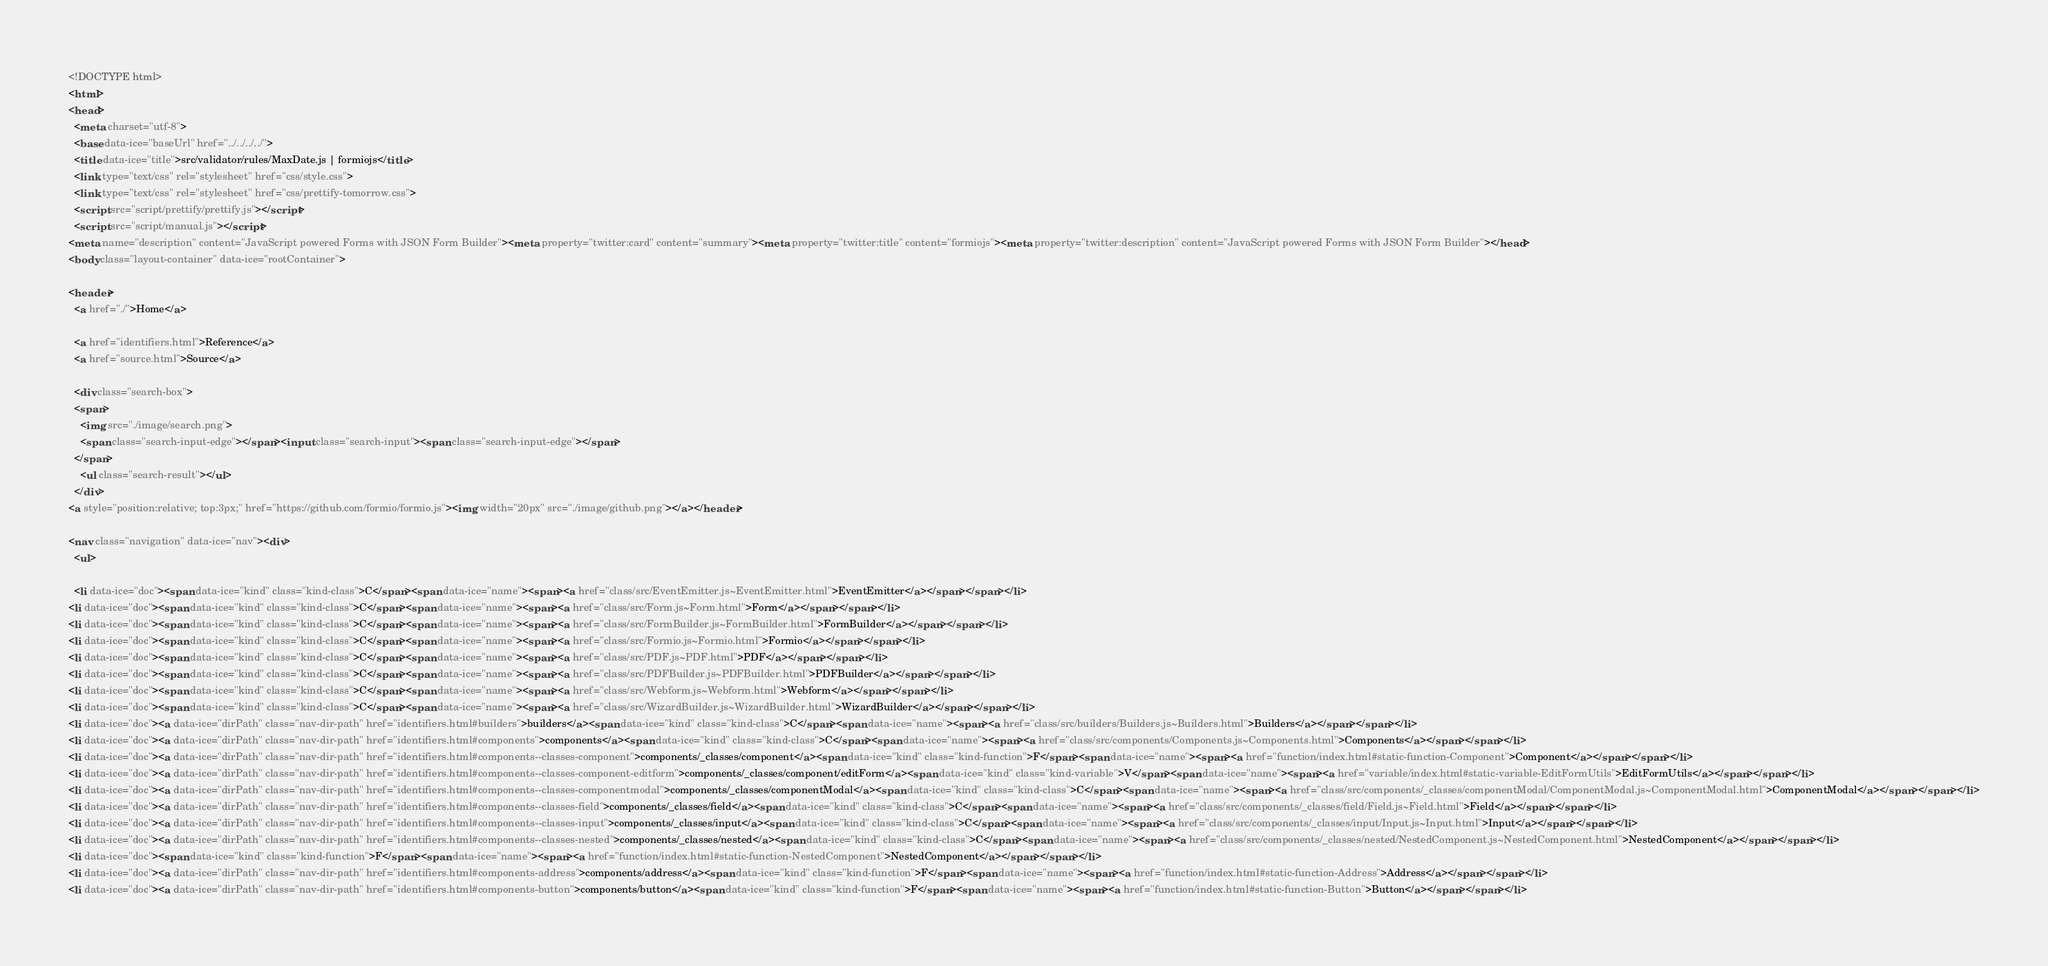<code> <loc_0><loc_0><loc_500><loc_500><_HTML_><!DOCTYPE html>
<html>
<head>
  <meta charset="utf-8">
  <base data-ice="baseUrl" href="../../../../">
  <title data-ice="title">src/validator/rules/MaxDate.js | formiojs</title>
  <link type="text/css" rel="stylesheet" href="css/style.css">
  <link type="text/css" rel="stylesheet" href="css/prettify-tomorrow.css">
  <script src="script/prettify/prettify.js"></script>
  <script src="script/manual.js"></script>
<meta name="description" content="JavaScript powered Forms with JSON Form Builder"><meta property="twitter:card" content="summary"><meta property="twitter:title" content="formiojs"><meta property="twitter:description" content="JavaScript powered Forms with JSON Form Builder"></head>
<body class="layout-container" data-ice="rootContainer">

<header>
  <a href="./">Home</a>
  
  <a href="identifiers.html">Reference</a>
  <a href="source.html">Source</a>
  
  <div class="search-box">
  <span>
    <img src="./image/search.png">
    <span class="search-input-edge"></span><input class="search-input"><span class="search-input-edge"></span>
  </span>
    <ul class="search-result"></ul>
  </div>
<a style="position:relative; top:3px;" href="https://github.com/formio/formio.js"><img width="20px" src="./image/github.png"></a></header>

<nav class="navigation" data-ice="nav"><div>
  <ul>
    
  <li data-ice="doc"><span data-ice="kind" class="kind-class">C</span><span data-ice="name"><span><a href="class/src/EventEmitter.js~EventEmitter.html">EventEmitter</a></span></span></li>
<li data-ice="doc"><span data-ice="kind" class="kind-class">C</span><span data-ice="name"><span><a href="class/src/Form.js~Form.html">Form</a></span></span></li>
<li data-ice="doc"><span data-ice="kind" class="kind-class">C</span><span data-ice="name"><span><a href="class/src/FormBuilder.js~FormBuilder.html">FormBuilder</a></span></span></li>
<li data-ice="doc"><span data-ice="kind" class="kind-class">C</span><span data-ice="name"><span><a href="class/src/Formio.js~Formio.html">Formio</a></span></span></li>
<li data-ice="doc"><span data-ice="kind" class="kind-class">C</span><span data-ice="name"><span><a href="class/src/PDF.js~PDF.html">PDF</a></span></span></li>
<li data-ice="doc"><span data-ice="kind" class="kind-class">C</span><span data-ice="name"><span><a href="class/src/PDFBuilder.js~PDFBuilder.html">PDFBuilder</a></span></span></li>
<li data-ice="doc"><span data-ice="kind" class="kind-class">C</span><span data-ice="name"><span><a href="class/src/Webform.js~Webform.html">Webform</a></span></span></li>
<li data-ice="doc"><span data-ice="kind" class="kind-class">C</span><span data-ice="name"><span><a href="class/src/WizardBuilder.js~WizardBuilder.html">WizardBuilder</a></span></span></li>
<li data-ice="doc"><a data-ice="dirPath" class="nav-dir-path" href="identifiers.html#builders">builders</a><span data-ice="kind" class="kind-class">C</span><span data-ice="name"><span><a href="class/src/builders/Builders.js~Builders.html">Builders</a></span></span></li>
<li data-ice="doc"><a data-ice="dirPath" class="nav-dir-path" href="identifiers.html#components">components</a><span data-ice="kind" class="kind-class">C</span><span data-ice="name"><span><a href="class/src/components/Components.js~Components.html">Components</a></span></span></li>
<li data-ice="doc"><a data-ice="dirPath" class="nav-dir-path" href="identifiers.html#components--classes-component">components/_classes/component</a><span data-ice="kind" class="kind-function">F</span><span data-ice="name"><span><a href="function/index.html#static-function-Component">Component</a></span></span></li>
<li data-ice="doc"><a data-ice="dirPath" class="nav-dir-path" href="identifiers.html#components--classes-component-editform">components/_classes/component/editForm</a><span data-ice="kind" class="kind-variable">V</span><span data-ice="name"><span><a href="variable/index.html#static-variable-EditFormUtils">EditFormUtils</a></span></span></li>
<li data-ice="doc"><a data-ice="dirPath" class="nav-dir-path" href="identifiers.html#components--classes-componentmodal">components/_classes/componentModal</a><span data-ice="kind" class="kind-class">C</span><span data-ice="name"><span><a href="class/src/components/_classes/componentModal/ComponentModal.js~ComponentModal.html">ComponentModal</a></span></span></li>
<li data-ice="doc"><a data-ice="dirPath" class="nav-dir-path" href="identifiers.html#components--classes-field">components/_classes/field</a><span data-ice="kind" class="kind-class">C</span><span data-ice="name"><span><a href="class/src/components/_classes/field/Field.js~Field.html">Field</a></span></span></li>
<li data-ice="doc"><a data-ice="dirPath" class="nav-dir-path" href="identifiers.html#components--classes-input">components/_classes/input</a><span data-ice="kind" class="kind-class">C</span><span data-ice="name"><span><a href="class/src/components/_classes/input/Input.js~Input.html">Input</a></span></span></li>
<li data-ice="doc"><a data-ice="dirPath" class="nav-dir-path" href="identifiers.html#components--classes-nested">components/_classes/nested</a><span data-ice="kind" class="kind-class">C</span><span data-ice="name"><span><a href="class/src/components/_classes/nested/NestedComponent.js~NestedComponent.html">NestedComponent</a></span></span></li>
<li data-ice="doc"><span data-ice="kind" class="kind-function">F</span><span data-ice="name"><span><a href="function/index.html#static-function-NestedComponent">NestedComponent</a></span></span></li>
<li data-ice="doc"><a data-ice="dirPath" class="nav-dir-path" href="identifiers.html#components-address">components/address</a><span data-ice="kind" class="kind-function">F</span><span data-ice="name"><span><a href="function/index.html#static-function-Address">Address</a></span></span></li>
<li data-ice="doc"><a data-ice="dirPath" class="nav-dir-path" href="identifiers.html#components-button">components/button</a><span data-ice="kind" class="kind-function">F</span><span data-ice="name"><span><a href="function/index.html#static-function-Button">Button</a></span></span></li></code> 